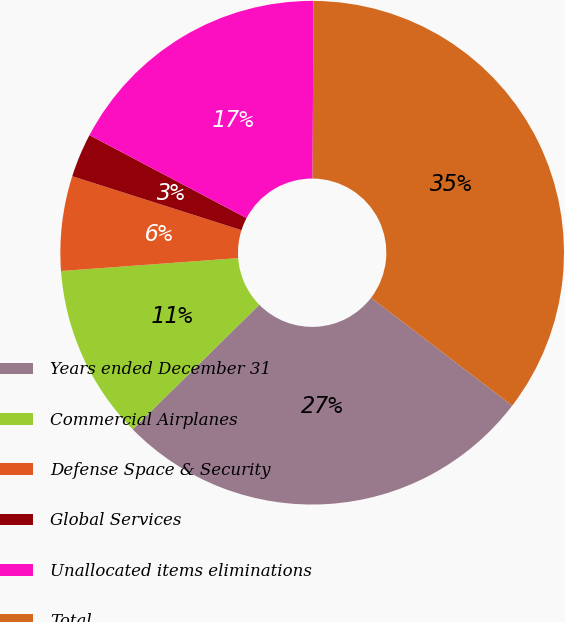<chart> <loc_0><loc_0><loc_500><loc_500><pie_chart><fcel>Years ended December 31<fcel>Commercial Airplanes<fcel>Defense Space & Security<fcel>Global Services<fcel>Unallocated items eliminations<fcel>Total<nl><fcel>27.24%<fcel>11.21%<fcel>6.07%<fcel>2.82%<fcel>17.35%<fcel>35.3%<nl></chart> 